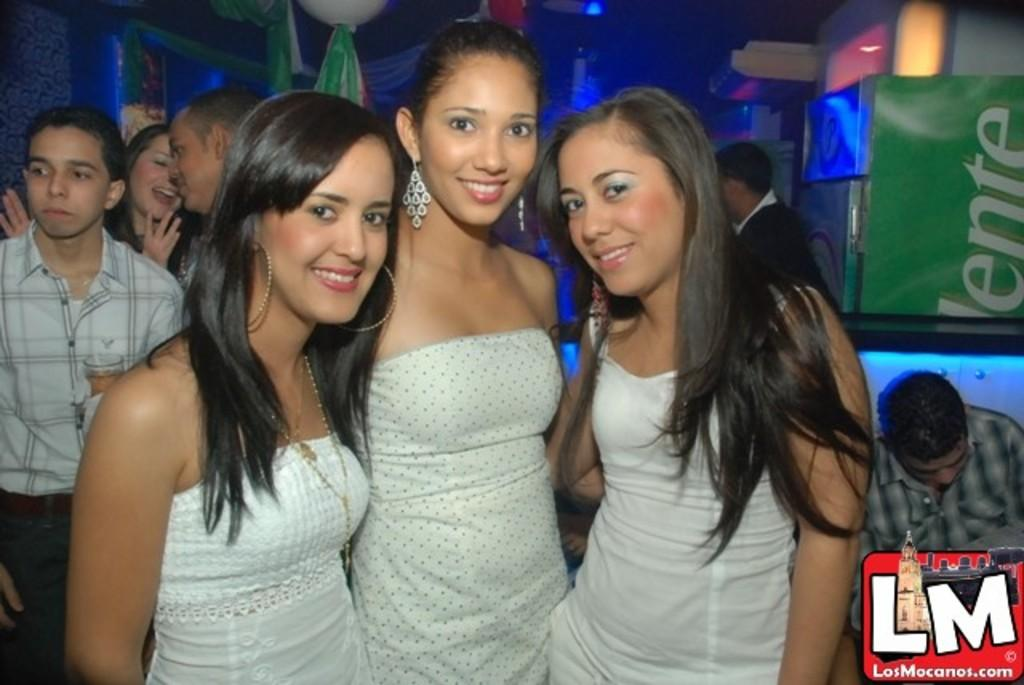How many girls are in the image? There are three girls in the image. What are the girls wearing? The girls are wearing white dresses. What can be seen in the background of the image? There are many people in the background of the image. Where might this image have been taken? The image appears to be taken in a pub. What type of animal can be seen playing with a grape in the image? There is no animal or grape present in the image; it features three girls wearing white dresses in a crowded background. 